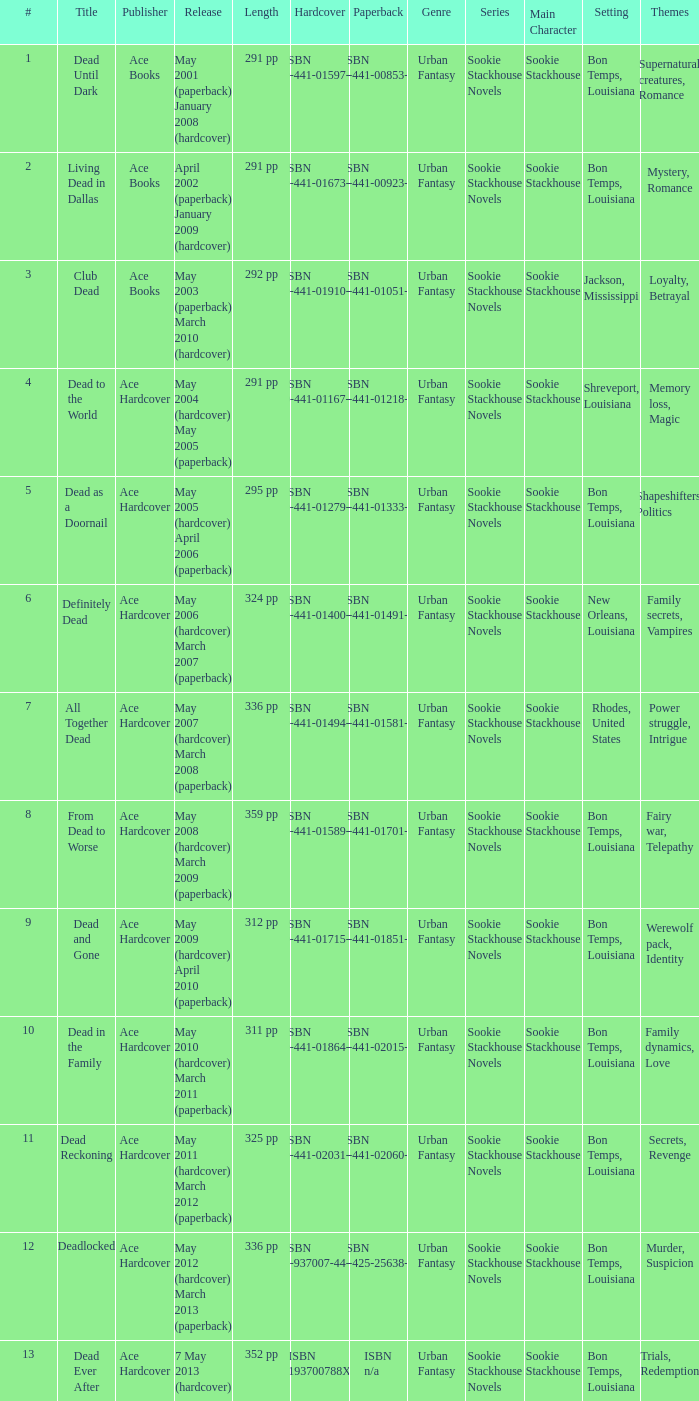Can you identify the publisher of the book with isbn 1-937007-44-8? Ace Hardcover. 